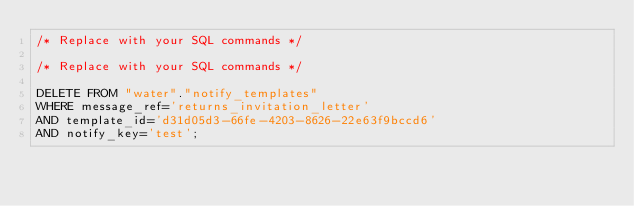<code> <loc_0><loc_0><loc_500><loc_500><_SQL_>/* Replace with your SQL commands */

/* Replace with your SQL commands */

DELETE FROM "water"."notify_templates"
WHERE message_ref='returns_invitation_letter'
AND template_id='d31d05d3-66fe-4203-8626-22e63f9bccd6'
AND notify_key='test';
</code> 